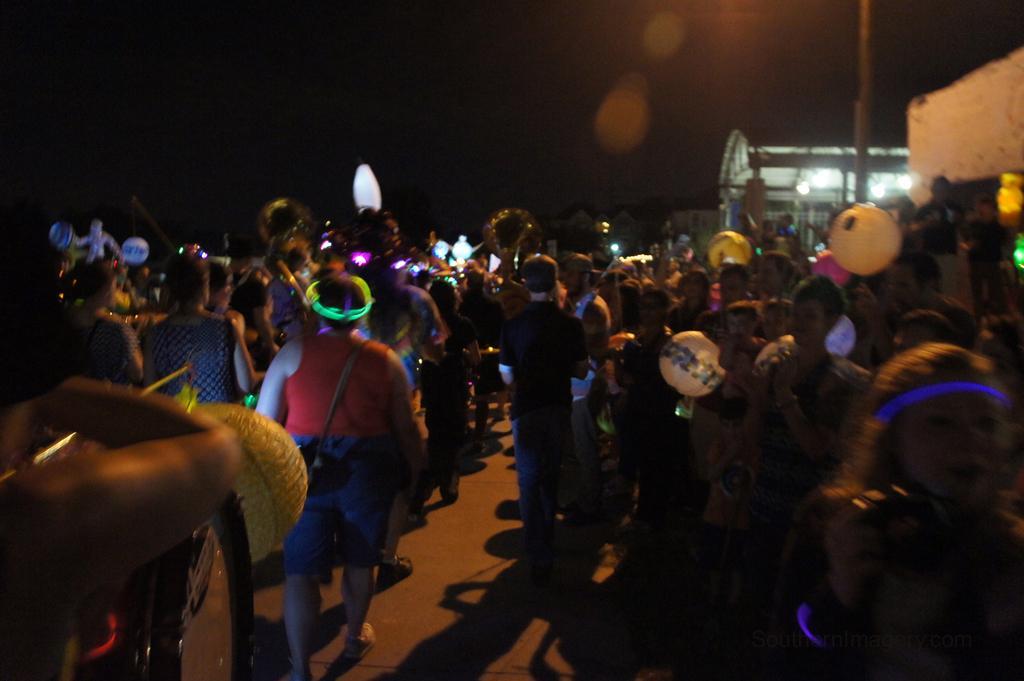In one or two sentences, can you explain what this image depicts? Here some people are standing and some people are walking, here there is a building, this is sky. 